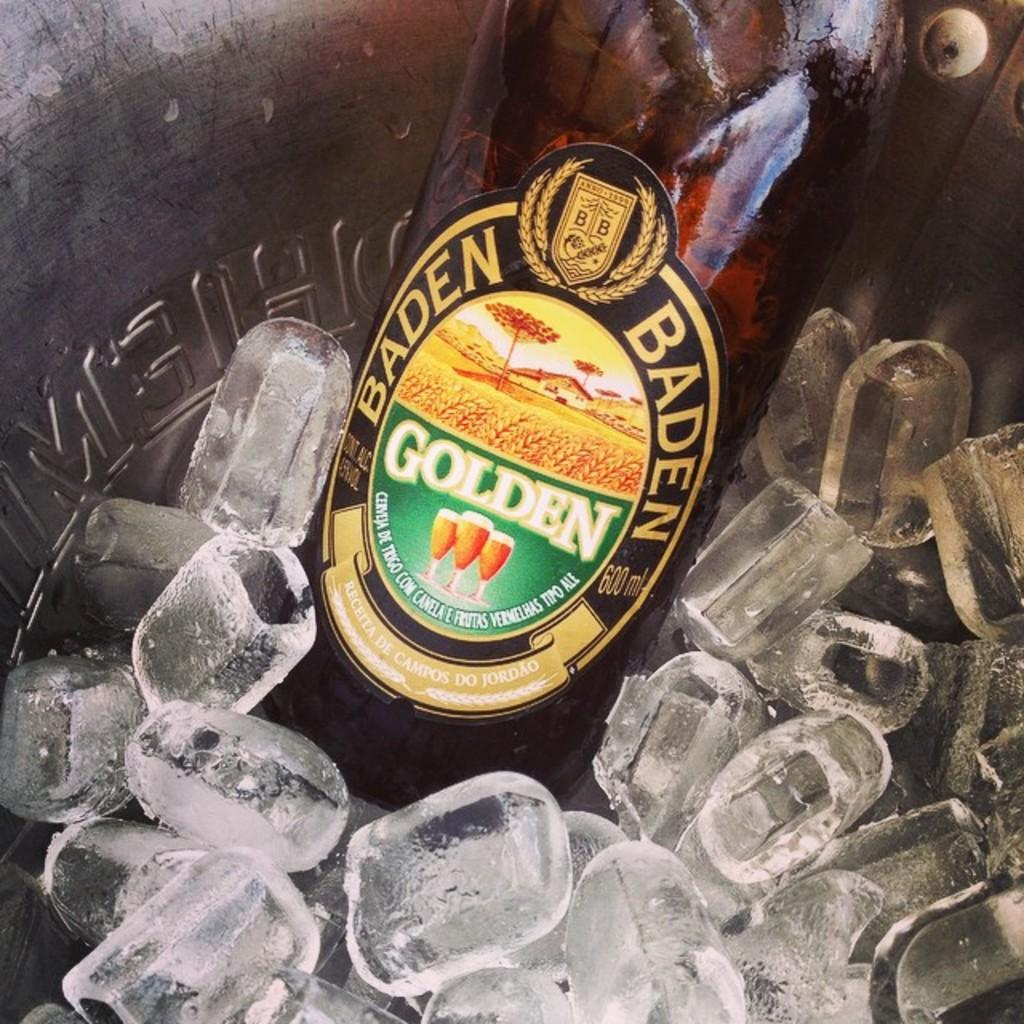<image>
Relay a brief, clear account of the picture shown. Baden Golden Ale beer drink that is in a container of ice. 